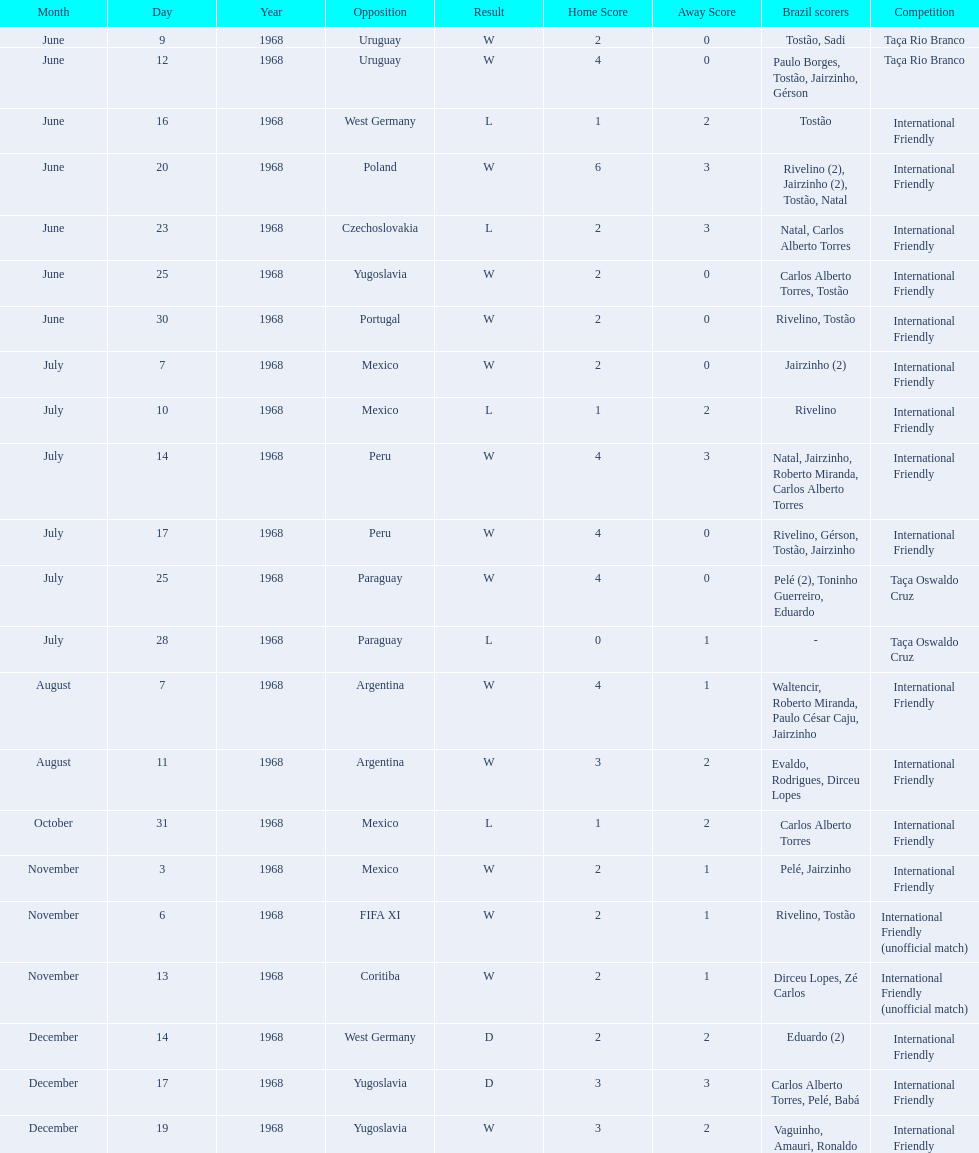What is the number of countries they have played? 11. 